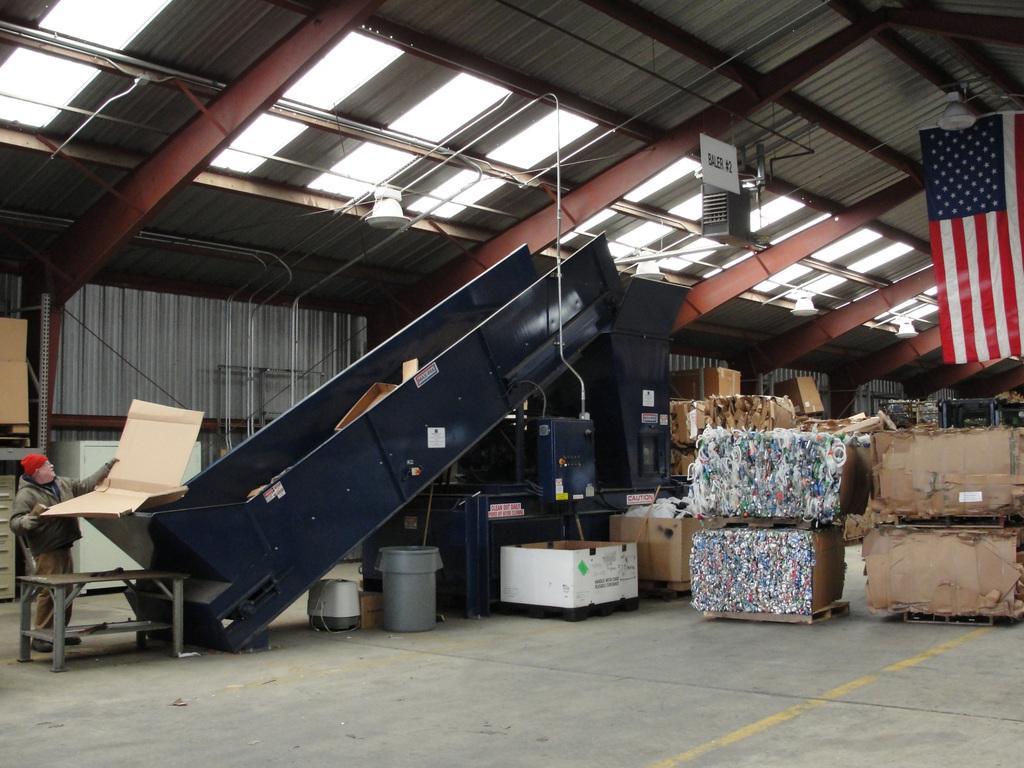Please provide a concise description of this image. In this picture we can see a person is standing and holding a cardboard sheet. In front of the person there is a machine and on the right side of the machine there are some cardboard sheets and some objects. Behind the person there is an iron wall and at the top there is a flag and they are looking like lights and iron rods. 